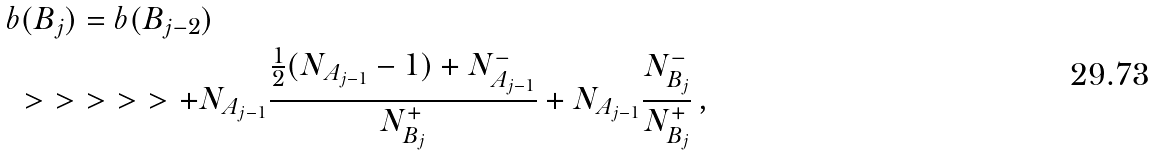Convert formula to latex. <formula><loc_0><loc_0><loc_500><loc_500>& b ( B _ { j } ) = b ( B _ { j - 2 } ) \\ & \ > \ > \ > \ > \ > + N _ { A _ { j - 1 } } \frac { \frac { 1 } { 2 } ( N _ { A _ { j - 1 } } - 1 ) + N _ { A _ { j - 1 } } ^ { - } } { N _ { B _ { j } } ^ { + } } + N _ { A _ { j - 1 } } \frac { N _ { B _ { j } } ^ { - } } { N _ { B _ { j } } ^ { + } } \, ,</formula> 